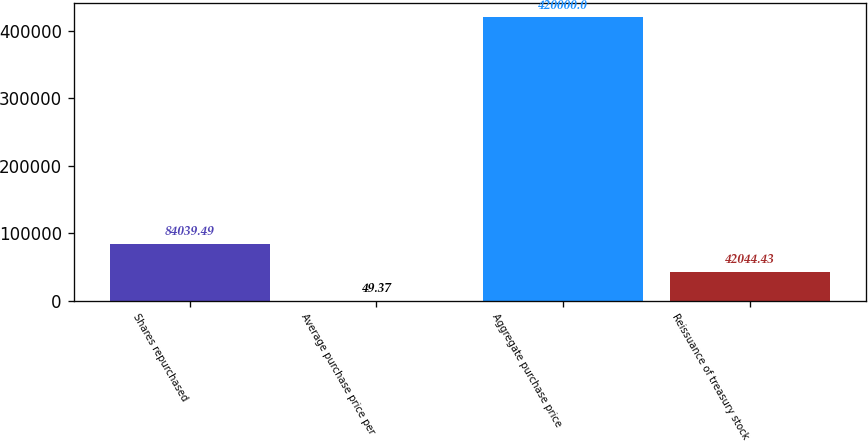Convert chart. <chart><loc_0><loc_0><loc_500><loc_500><bar_chart><fcel>Shares repurchased<fcel>Average purchase price per<fcel>Aggregate purchase price<fcel>Reissuance of treasury stock<nl><fcel>84039.5<fcel>49.37<fcel>420000<fcel>42044.4<nl></chart> 